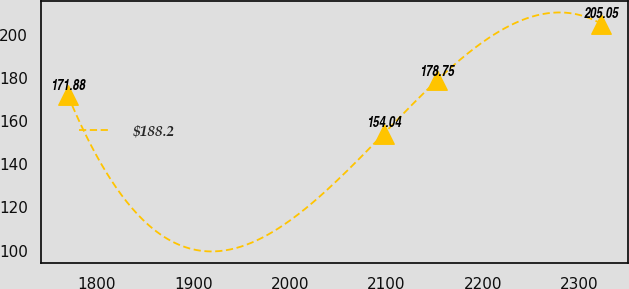Convert chart to OTSL. <chart><loc_0><loc_0><loc_500><loc_500><line_chart><ecel><fcel>$188.2<nl><fcel>1770.33<fcel>171.88<nl><fcel>2097.11<fcel>154.04<nl><fcel>2152.3<fcel>178.75<nl><fcel>2322.2<fcel>205.05<nl></chart> 